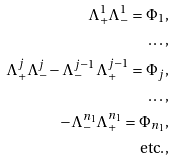<formula> <loc_0><loc_0><loc_500><loc_500>\Lambda _ { + } ^ { 1 } \Lambda _ { - } ^ { 1 } = \Phi _ { 1 } , \\ \dots , \\ \Lambda _ { + } ^ { j } \Lambda _ { - } ^ { j } - \Lambda _ { - } ^ { j - 1 } \Lambda _ { + } ^ { j - 1 } = \Phi _ { j } , \\ \dots , \\ - \Lambda _ { - } ^ { n _ { 1 } } \Lambda _ { + } ^ { n _ { 1 } } = \Phi _ { n _ { 1 } } , \\ \text {etc.} ,</formula> 